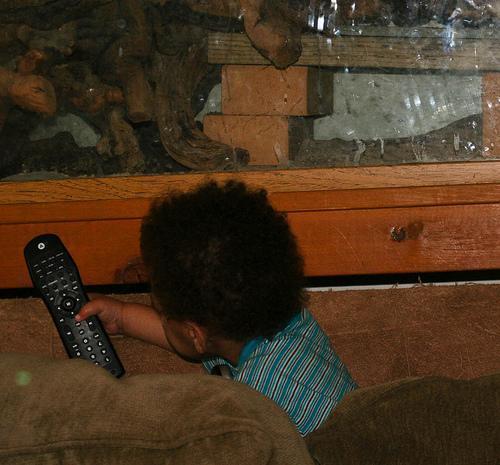What is the glass container likely to be?
Make your selection from the four choices given to correctly answer the question.
Options: Bookshelf, tv stand, fish tank, china cabinet. Fish tank. 